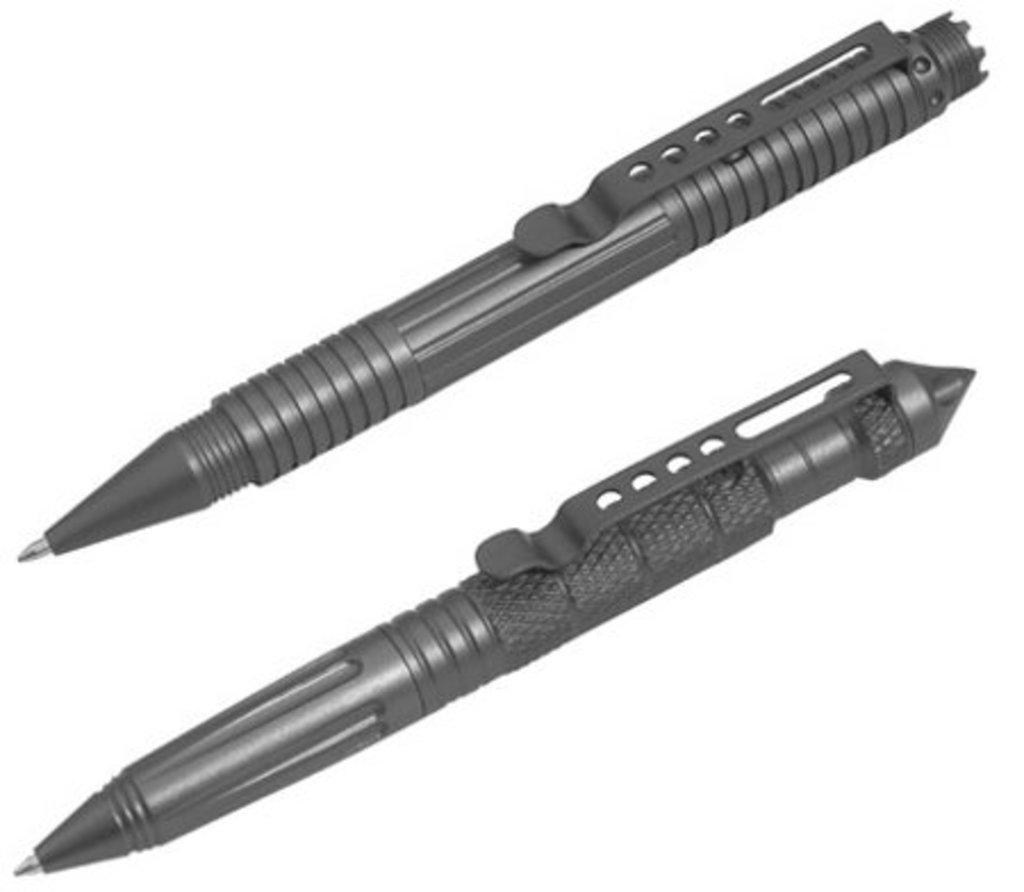How many different designs of pens are in the image? There are two different designs of pens in the image. What colors are the pens in the image? The pens are black and gray in color. How many houses can be seen in the image? There are no houses present in the image; it features two different designs of pens in black and gray colors. 